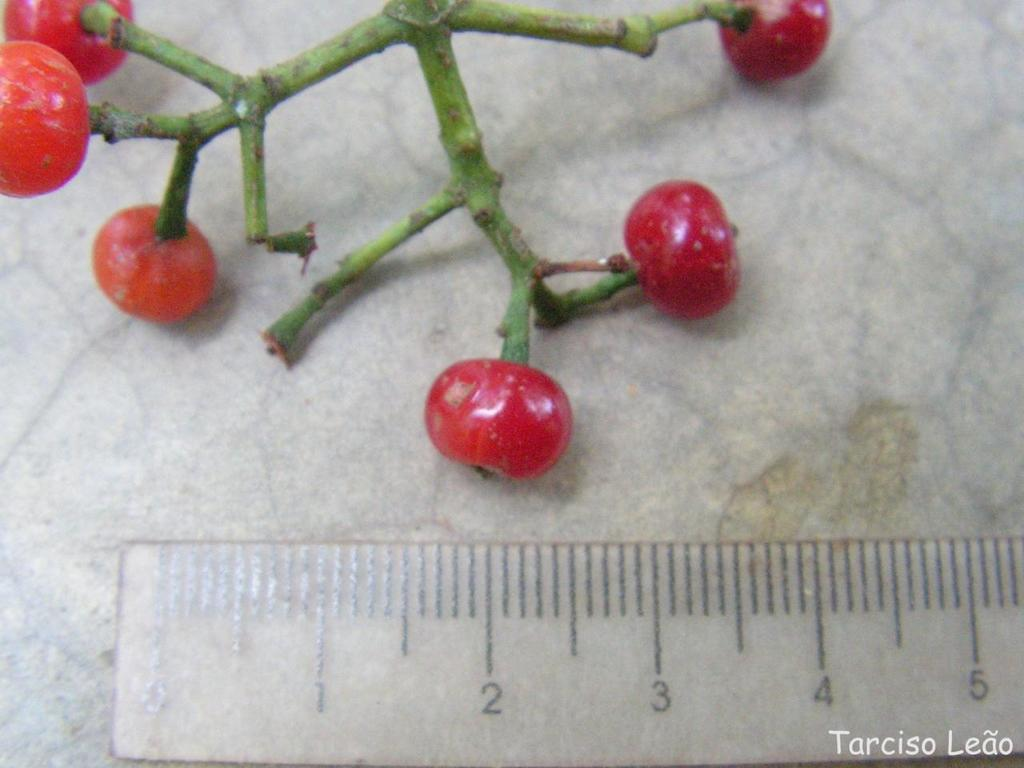<image>
Render a clear and concise summary of the photo. Red cherries being measured on a ruler with the name "Tarciso Leao" on the bottom. 